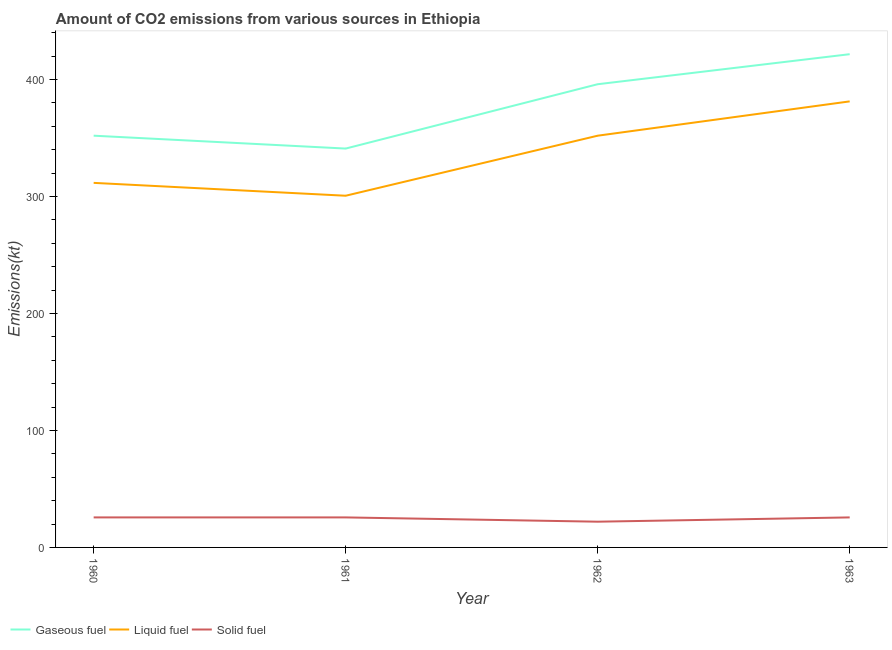Does the line corresponding to amount of co2 emissions from solid fuel intersect with the line corresponding to amount of co2 emissions from liquid fuel?
Ensure brevity in your answer.  No. What is the amount of co2 emissions from gaseous fuel in 1960?
Offer a very short reply. 352.03. Across all years, what is the maximum amount of co2 emissions from liquid fuel?
Your answer should be very brief. 381.37. Across all years, what is the minimum amount of co2 emissions from gaseous fuel?
Your answer should be compact. 341.03. In which year was the amount of co2 emissions from solid fuel maximum?
Ensure brevity in your answer.  1960. What is the total amount of co2 emissions from gaseous fuel in the graph?
Provide a short and direct response. 1510.8. What is the difference between the amount of co2 emissions from gaseous fuel in 1961 and that in 1962?
Your answer should be very brief. -55. What is the difference between the amount of co2 emissions from liquid fuel in 1963 and the amount of co2 emissions from solid fuel in 1960?
Ensure brevity in your answer.  355.7. What is the average amount of co2 emissions from liquid fuel per year?
Your answer should be very brief. 336.45. In the year 1960, what is the difference between the amount of co2 emissions from gaseous fuel and amount of co2 emissions from liquid fuel?
Provide a short and direct response. 40.34. In how many years, is the amount of co2 emissions from gaseous fuel greater than 140 kt?
Give a very brief answer. 4. What is the ratio of the amount of co2 emissions from liquid fuel in 1960 to that in 1963?
Make the answer very short. 0.82. Is the difference between the amount of co2 emissions from gaseous fuel in 1961 and 1962 greater than the difference between the amount of co2 emissions from solid fuel in 1961 and 1962?
Your answer should be very brief. No. What is the difference between the highest and the second highest amount of co2 emissions from gaseous fuel?
Keep it short and to the point. 25.67. What is the difference between the highest and the lowest amount of co2 emissions from liquid fuel?
Keep it short and to the point. 80.67. In how many years, is the amount of co2 emissions from solid fuel greater than the average amount of co2 emissions from solid fuel taken over all years?
Offer a very short reply. 3. Is the sum of the amount of co2 emissions from liquid fuel in 1960 and 1962 greater than the maximum amount of co2 emissions from solid fuel across all years?
Offer a terse response. Yes. Is it the case that in every year, the sum of the amount of co2 emissions from gaseous fuel and amount of co2 emissions from liquid fuel is greater than the amount of co2 emissions from solid fuel?
Your answer should be compact. Yes. Is the amount of co2 emissions from gaseous fuel strictly less than the amount of co2 emissions from solid fuel over the years?
Offer a terse response. No. How many years are there in the graph?
Provide a succinct answer. 4. Are the values on the major ticks of Y-axis written in scientific E-notation?
Keep it short and to the point. No. Does the graph contain any zero values?
Keep it short and to the point. No. How many legend labels are there?
Provide a short and direct response. 3. How are the legend labels stacked?
Your answer should be compact. Horizontal. What is the title of the graph?
Ensure brevity in your answer.  Amount of CO2 emissions from various sources in Ethiopia. What is the label or title of the X-axis?
Provide a succinct answer. Year. What is the label or title of the Y-axis?
Provide a succinct answer. Emissions(kt). What is the Emissions(kt) in Gaseous fuel in 1960?
Ensure brevity in your answer.  352.03. What is the Emissions(kt) in Liquid fuel in 1960?
Provide a succinct answer. 311.69. What is the Emissions(kt) of Solid fuel in 1960?
Your response must be concise. 25.67. What is the Emissions(kt) in Gaseous fuel in 1961?
Provide a short and direct response. 341.03. What is the Emissions(kt) of Liquid fuel in 1961?
Your answer should be compact. 300.69. What is the Emissions(kt) of Solid fuel in 1961?
Ensure brevity in your answer.  25.67. What is the Emissions(kt) in Gaseous fuel in 1962?
Your answer should be very brief. 396.04. What is the Emissions(kt) of Liquid fuel in 1962?
Your answer should be very brief. 352.03. What is the Emissions(kt) in Solid fuel in 1962?
Keep it short and to the point. 22. What is the Emissions(kt) of Gaseous fuel in 1963?
Your answer should be very brief. 421.7. What is the Emissions(kt) of Liquid fuel in 1963?
Keep it short and to the point. 381.37. What is the Emissions(kt) in Solid fuel in 1963?
Offer a terse response. 25.67. Across all years, what is the maximum Emissions(kt) of Gaseous fuel?
Your answer should be very brief. 421.7. Across all years, what is the maximum Emissions(kt) of Liquid fuel?
Provide a short and direct response. 381.37. Across all years, what is the maximum Emissions(kt) in Solid fuel?
Ensure brevity in your answer.  25.67. Across all years, what is the minimum Emissions(kt) in Gaseous fuel?
Your answer should be very brief. 341.03. Across all years, what is the minimum Emissions(kt) of Liquid fuel?
Keep it short and to the point. 300.69. Across all years, what is the minimum Emissions(kt) in Solid fuel?
Make the answer very short. 22. What is the total Emissions(kt) of Gaseous fuel in the graph?
Make the answer very short. 1510.8. What is the total Emissions(kt) in Liquid fuel in the graph?
Offer a very short reply. 1345.79. What is the total Emissions(kt) of Solid fuel in the graph?
Your response must be concise. 99.01. What is the difference between the Emissions(kt) in Gaseous fuel in 1960 and that in 1961?
Make the answer very short. 11. What is the difference between the Emissions(kt) of Liquid fuel in 1960 and that in 1961?
Your response must be concise. 11. What is the difference between the Emissions(kt) in Solid fuel in 1960 and that in 1961?
Your response must be concise. 0. What is the difference between the Emissions(kt) of Gaseous fuel in 1960 and that in 1962?
Offer a very short reply. -44. What is the difference between the Emissions(kt) in Liquid fuel in 1960 and that in 1962?
Provide a short and direct response. -40.34. What is the difference between the Emissions(kt) in Solid fuel in 1960 and that in 1962?
Make the answer very short. 3.67. What is the difference between the Emissions(kt) of Gaseous fuel in 1960 and that in 1963?
Your answer should be compact. -69.67. What is the difference between the Emissions(kt) of Liquid fuel in 1960 and that in 1963?
Give a very brief answer. -69.67. What is the difference between the Emissions(kt) of Solid fuel in 1960 and that in 1963?
Offer a very short reply. 0. What is the difference between the Emissions(kt) in Gaseous fuel in 1961 and that in 1962?
Ensure brevity in your answer.  -55.01. What is the difference between the Emissions(kt) in Liquid fuel in 1961 and that in 1962?
Give a very brief answer. -51.34. What is the difference between the Emissions(kt) of Solid fuel in 1961 and that in 1962?
Provide a short and direct response. 3.67. What is the difference between the Emissions(kt) of Gaseous fuel in 1961 and that in 1963?
Give a very brief answer. -80.67. What is the difference between the Emissions(kt) in Liquid fuel in 1961 and that in 1963?
Offer a very short reply. -80.67. What is the difference between the Emissions(kt) in Gaseous fuel in 1962 and that in 1963?
Your response must be concise. -25.67. What is the difference between the Emissions(kt) of Liquid fuel in 1962 and that in 1963?
Make the answer very short. -29.34. What is the difference between the Emissions(kt) in Solid fuel in 1962 and that in 1963?
Offer a terse response. -3.67. What is the difference between the Emissions(kt) of Gaseous fuel in 1960 and the Emissions(kt) of Liquid fuel in 1961?
Your response must be concise. 51.34. What is the difference between the Emissions(kt) in Gaseous fuel in 1960 and the Emissions(kt) in Solid fuel in 1961?
Your answer should be compact. 326.36. What is the difference between the Emissions(kt) in Liquid fuel in 1960 and the Emissions(kt) in Solid fuel in 1961?
Ensure brevity in your answer.  286.03. What is the difference between the Emissions(kt) of Gaseous fuel in 1960 and the Emissions(kt) of Liquid fuel in 1962?
Provide a short and direct response. 0. What is the difference between the Emissions(kt) in Gaseous fuel in 1960 and the Emissions(kt) in Solid fuel in 1962?
Your response must be concise. 330.03. What is the difference between the Emissions(kt) of Liquid fuel in 1960 and the Emissions(kt) of Solid fuel in 1962?
Give a very brief answer. 289.69. What is the difference between the Emissions(kt) in Gaseous fuel in 1960 and the Emissions(kt) in Liquid fuel in 1963?
Provide a short and direct response. -29.34. What is the difference between the Emissions(kt) of Gaseous fuel in 1960 and the Emissions(kt) of Solid fuel in 1963?
Your answer should be compact. 326.36. What is the difference between the Emissions(kt) of Liquid fuel in 1960 and the Emissions(kt) of Solid fuel in 1963?
Keep it short and to the point. 286.03. What is the difference between the Emissions(kt) in Gaseous fuel in 1961 and the Emissions(kt) in Liquid fuel in 1962?
Ensure brevity in your answer.  -11. What is the difference between the Emissions(kt) of Gaseous fuel in 1961 and the Emissions(kt) of Solid fuel in 1962?
Offer a very short reply. 319.03. What is the difference between the Emissions(kt) of Liquid fuel in 1961 and the Emissions(kt) of Solid fuel in 1962?
Your answer should be compact. 278.69. What is the difference between the Emissions(kt) in Gaseous fuel in 1961 and the Emissions(kt) in Liquid fuel in 1963?
Your response must be concise. -40.34. What is the difference between the Emissions(kt) in Gaseous fuel in 1961 and the Emissions(kt) in Solid fuel in 1963?
Make the answer very short. 315.36. What is the difference between the Emissions(kt) of Liquid fuel in 1961 and the Emissions(kt) of Solid fuel in 1963?
Give a very brief answer. 275.02. What is the difference between the Emissions(kt) of Gaseous fuel in 1962 and the Emissions(kt) of Liquid fuel in 1963?
Keep it short and to the point. 14.67. What is the difference between the Emissions(kt) in Gaseous fuel in 1962 and the Emissions(kt) in Solid fuel in 1963?
Give a very brief answer. 370.37. What is the difference between the Emissions(kt) in Liquid fuel in 1962 and the Emissions(kt) in Solid fuel in 1963?
Offer a very short reply. 326.36. What is the average Emissions(kt) of Gaseous fuel per year?
Your answer should be very brief. 377.7. What is the average Emissions(kt) in Liquid fuel per year?
Keep it short and to the point. 336.45. What is the average Emissions(kt) in Solid fuel per year?
Provide a short and direct response. 24.75. In the year 1960, what is the difference between the Emissions(kt) of Gaseous fuel and Emissions(kt) of Liquid fuel?
Offer a terse response. 40.34. In the year 1960, what is the difference between the Emissions(kt) in Gaseous fuel and Emissions(kt) in Solid fuel?
Give a very brief answer. 326.36. In the year 1960, what is the difference between the Emissions(kt) in Liquid fuel and Emissions(kt) in Solid fuel?
Offer a terse response. 286.03. In the year 1961, what is the difference between the Emissions(kt) in Gaseous fuel and Emissions(kt) in Liquid fuel?
Keep it short and to the point. 40.34. In the year 1961, what is the difference between the Emissions(kt) of Gaseous fuel and Emissions(kt) of Solid fuel?
Your answer should be very brief. 315.36. In the year 1961, what is the difference between the Emissions(kt) in Liquid fuel and Emissions(kt) in Solid fuel?
Provide a succinct answer. 275.02. In the year 1962, what is the difference between the Emissions(kt) in Gaseous fuel and Emissions(kt) in Liquid fuel?
Give a very brief answer. 44. In the year 1962, what is the difference between the Emissions(kt) of Gaseous fuel and Emissions(kt) of Solid fuel?
Ensure brevity in your answer.  374.03. In the year 1962, what is the difference between the Emissions(kt) of Liquid fuel and Emissions(kt) of Solid fuel?
Keep it short and to the point. 330.03. In the year 1963, what is the difference between the Emissions(kt) in Gaseous fuel and Emissions(kt) in Liquid fuel?
Make the answer very short. 40.34. In the year 1963, what is the difference between the Emissions(kt) of Gaseous fuel and Emissions(kt) of Solid fuel?
Ensure brevity in your answer.  396.04. In the year 1963, what is the difference between the Emissions(kt) of Liquid fuel and Emissions(kt) of Solid fuel?
Give a very brief answer. 355.7. What is the ratio of the Emissions(kt) in Gaseous fuel in 1960 to that in 1961?
Your answer should be compact. 1.03. What is the ratio of the Emissions(kt) of Liquid fuel in 1960 to that in 1961?
Provide a succinct answer. 1.04. What is the ratio of the Emissions(kt) in Solid fuel in 1960 to that in 1961?
Ensure brevity in your answer.  1. What is the ratio of the Emissions(kt) of Liquid fuel in 1960 to that in 1962?
Offer a very short reply. 0.89. What is the ratio of the Emissions(kt) of Solid fuel in 1960 to that in 1962?
Your response must be concise. 1.17. What is the ratio of the Emissions(kt) in Gaseous fuel in 1960 to that in 1963?
Provide a succinct answer. 0.83. What is the ratio of the Emissions(kt) of Liquid fuel in 1960 to that in 1963?
Your answer should be very brief. 0.82. What is the ratio of the Emissions(kt) in Gaseous fuel in 1961 to that in 1962?
Offer a very short reply. 0.86. What is the ratio of the Emissions(kt) in Liquid fuel in 1961 to that in 1962?
Provide a short and direct response. 0.85. What is the ratio of the Emissions(kt) in Solid fuel in 1961 to that in 1962?
Offer a very short reply. 1.17. What is the ratio of the Emissions(kt) of Gaseous fuel in 1961 to that in 1963?
Keep it short and to the point. 0.81. What is the ratio of the Emissions(kt) in Liquid fuel in 1961 to that in 1963?
Your answer should be compact. 0.79. What is the ratio of the Emissions(kt) of Solid fuel in 1961 to that in 1963?
Ensure brevity in your answer.  1. What is the ratio of the Emissions(kt) of Gaseous fuel in 1962 to that in 1963?
Ensure brevity in your answer.  0.94. What is the ratio of the Emissions(kt) of Solid fuel in 1962 to that in 1963?
Your answer should be very brief. 0.86. What is the difference between the highest and the second highest Emissions(kt) of Gaseous fuel?
Your answer should be very brief. 25.67. What is the difference between the highest and the second highest Emissions(kt) in Liquid fuel?
Your answer should be compact. 29.34. What is the difference between the highest and the second highest Emissions(kt) of Solid fuel?
Provide a short and direct response. 0. What is the difference between the highest and the lowest Emissions(kt) in Gaseous fuel?
Offer a terse response. 80.67. What is the difference between the highest and the lowest Emissions(kt) in Liquid fuel?
Provide a short and direct response. 80.67. What is the difference between the highest and the lowest Emissions(kt) in Solid fuel?
Your answer should be very brief. 3.67. 